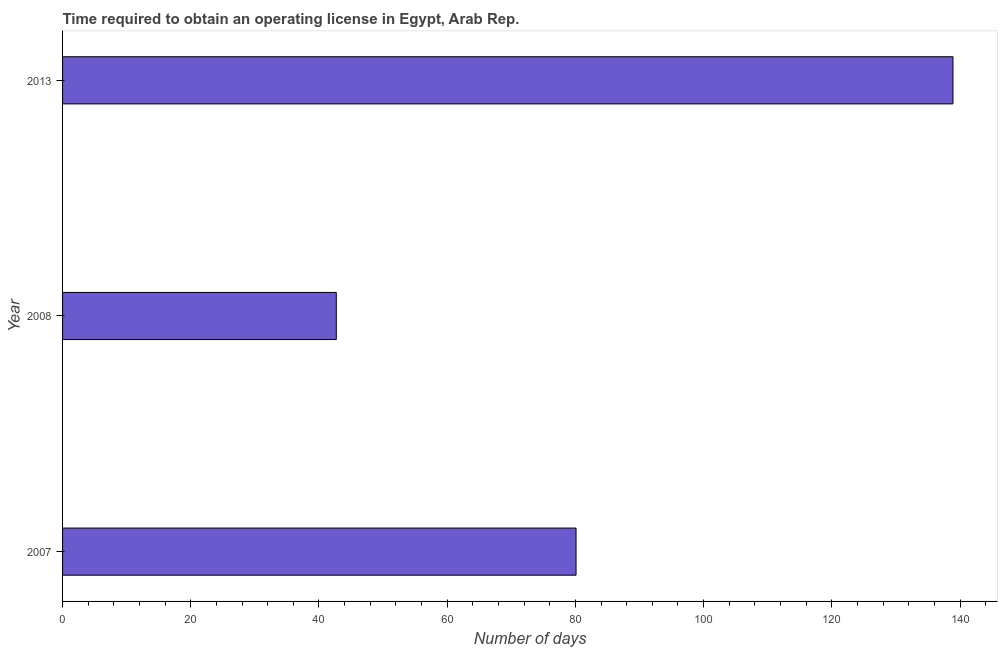Does the graph contain any zero values?
Make the answer very short. No. Does the graph contain grids?
Your response must be concise. No. What is the title of the graph?
Your response must be concise. Time required to obtain an operating license in Egypt, Arab Rep. What is the label or title of the X-axis?
Your answer should be very brief. Number of days. What is the number of days to obtain operating license in 2008?
Your response must be concise. 42.7. Across all years, what is the maximum number of days to obtain operating license?
Keep it short and to the point. 138.9. Across all years, what is the minimum number of days to obtain operating license?
Your answer should be very brief. 42.7. In which year was the number of days to obtain operating license maximum?
Your answer should be compact. 2013. In which year was the number of days to obtain operating license minimum?
Your answer should be compact. 2008. What is the sum of the number of days to obtain operating license?
Ensure brevity in your answer.  261.7. What is the difference between the number of days to obtain operating license in 2008 and 2013?
Keep it short and to the point. -96.2. What is the average number of days to obtain operating license per year?
Provide a succinct answer. 87.23. What is the median number of days to obtain operating license?
Make the answer very short. 80.1. In how many years, is the number of days to obtain operating license greater than 64 days?
Offer a terse response. 2. Do a majority of the years between 2008 and 2007 (inclusive) have number of days to obtain operating license greater than 136 days?
Your answer should be very brief. No. What is the ratio of the number of days to obtain operating license in 2007 to that in 2008?
Offer a very short reply. 1.88. Is the number of days to obtain operating license in 2008 less than that in 2013?
Your answer should be very brief. Yes. Is the difference between the number of days to obtain operating license in 2007 and 2008 greater than the difference between any two years?
Your response must be concise. No. What is the difference between the highest and the second highest number of days to obtain operating license?
Provide a succinct answer. 58.8. Is the sum of the number of days to obtain operating license in 2007 and 2013 greater than the maximum number of days to obtain operating license across all years?
Provide a short and direct response. Yes. What is the difference between the highest and the lowest number of days to obtain operating license?
Offer a very short reply. 96.2. How many bars are there?
Keep it short and to the point. 3. Are all the bars in the graph horizontal?
Your answer should be compact. Yes. What is the difference between two consecutive major ticks on the X-axis?
Provide a succinct answer. 20. Are the values on the major ticks of X-axis written in scientific E-notation?
Provide a succinct answer. No. What is the Number of days in 2007?
Make the answer very short. 80.1. What is the Number of days in 2008?
Provide a succinct answer. 42.7. What is the Number of days in 2013?
Provide a succinct answer. 138.9. What is the difference between the Number of days in 2007 and 2008?
Give a very brief answer. 37.4. What is the difference between the Number of days in 2007 and 2013?
Provide a short and direct response. -58.8. What is the difference between the Number of days in 2008 and 2013?
Offer a very short reply. -96.2. What is the ratio of the Number of days in 2007 to that in 2008?
Ensure brevity in your answer.  1.88. What is the ratio of the Number of days in 2007 to that in 2013?
Ensure brevity in your answer.  0.58. What is the ratio of the Number of days in 2008 to that in 2013?
Your answer should be compact. 0.31. 